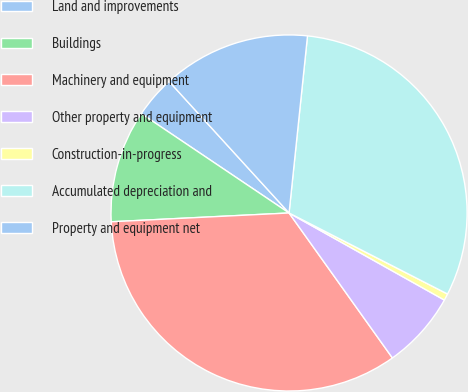Convert chart to OTSL. <chart><loc_0><loc_0><loc_500><loc_500><pie_chart><fcel>Land and improvements<fcel>Buildings<fcel>Machinery and equipment<fcel>Other property and equipment<fcel>Construction-in-progress<fcel>Accumulated depreciation and<fcel>Property and equipment net<nl><fcel>3.81%<fcel>10.21%<fcel>34.07%<fcel>7.01%<fcel>0.61%<fcel>30.87%<fcel>13.42%<nl></chart> 